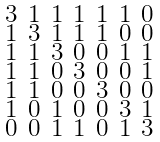<formula> <loc_0><loc_0><loc_500><loc_500>\begin{smallmatrix} 3 & 1 & 1 & 1 & 1 & 1 & 0 \\ 1 & 3 & 1 & 1 & 1 & 0 & 0 \\ 1 & 1 & 3 & 0 & 0 & 1 & 1 \\ 1 & 1 & 0 & 3 & 0 & 0 & 1 \\ 1 & 1 & 0 & 0 & 3 & 0 & 0 \\ 1 & 0 & 1 & 0 & 0 & 3 & 1 \\ 0 & 0 & 1 & 1 & 0 & 1 & 3 \end{smallmatrix}</formula> 